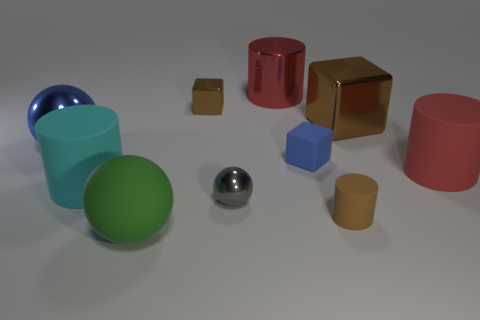Subtract all large green balls. How many balls are left? 2 Subtract all brown cubes. How many red cylinders are left? 2 Subtract all cyan cylinders. How many cylinders are left? 3 Subtract 3 cubes. How many cubes are left? 0 Subtract all spheres. How many objects are left? 7 Add 2 large cyan things. How many large cyan things exist? 3 Subtract 0 blue cylinders. How many objects are left? 10 Subtract all red blocks. Subtract all red cylinders. How many blocks are left? 3 Subtract all small brown shiny things. Subtract all red rubber things. How many objects are left? 8 Add 7 big cyan cylinders. How many big cyan cylinders are left? 8 